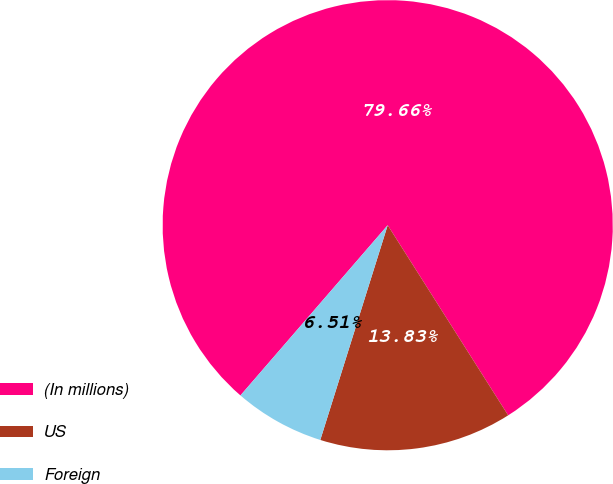<chart> <loc_0><loc_0><loc_500><loc_500><pie_chart><fcel>(In millions)<fcel>US<fcel>Foreign<nl><fcel>79.66%<fcel>13.83%<fcel>6.51%<nl></chart> 